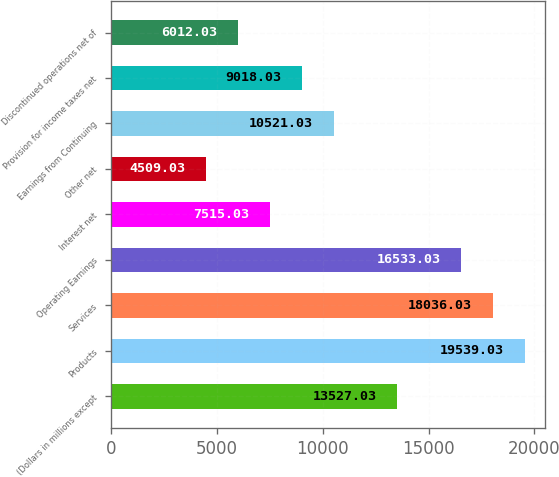Convert chart to OTSL. <chart><loc_0><loc_0><loc_500><loc_500><bar_chart><fcel>(Dollars in millions except<fcel>Products<fcel>Services<fcel>Operating Earnings<fcel>Interest net<fcel>Other net<fcel>Earnings from Continuing<fcel>Provision for income taxes net<fcel>Discontinued operations net of<nl><fcel>13527<fcel>19539<fcel>18036<fcel>16533<fcel>7515.03<fcel>4509.03<fcel>10521<fcel>9018.03<fcel>6012.03<nl></chart> 